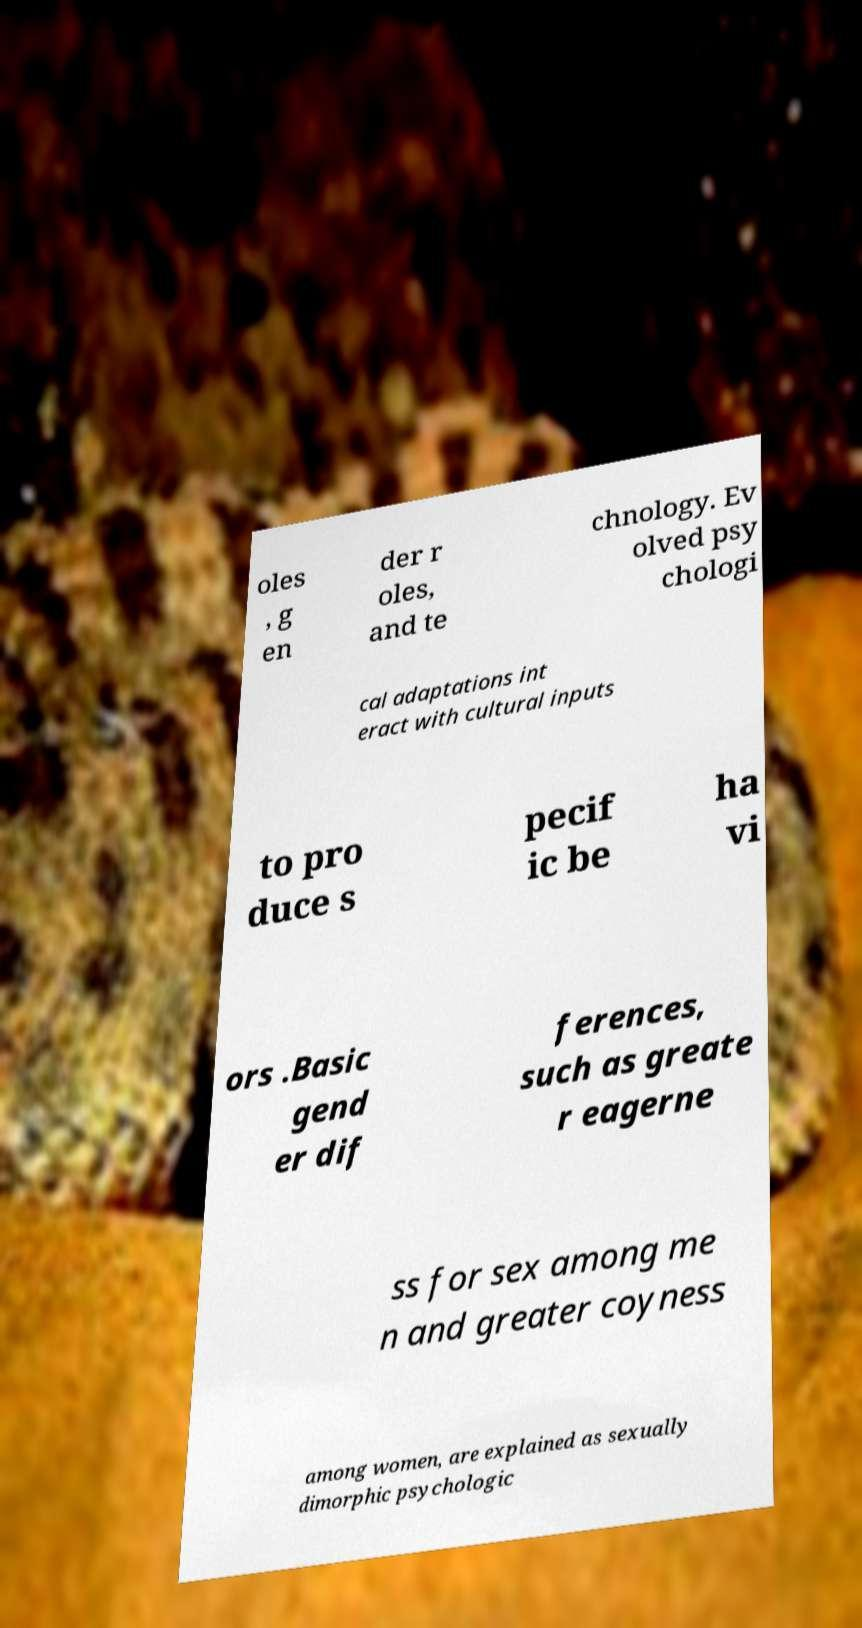Could you assist in decoding the text presented in this image and type it out clearly? oles , g en der r oles, and te chnology. Ev olved psy chologi cal adaptations int eract with cultural inputs to pro duce s pecif ic be ha vi ors .Basic gend er dif ferences, such as greate r eagerne ss for sex among me n and greater coyness among women, are explained as sexually dimorphic psychologic 